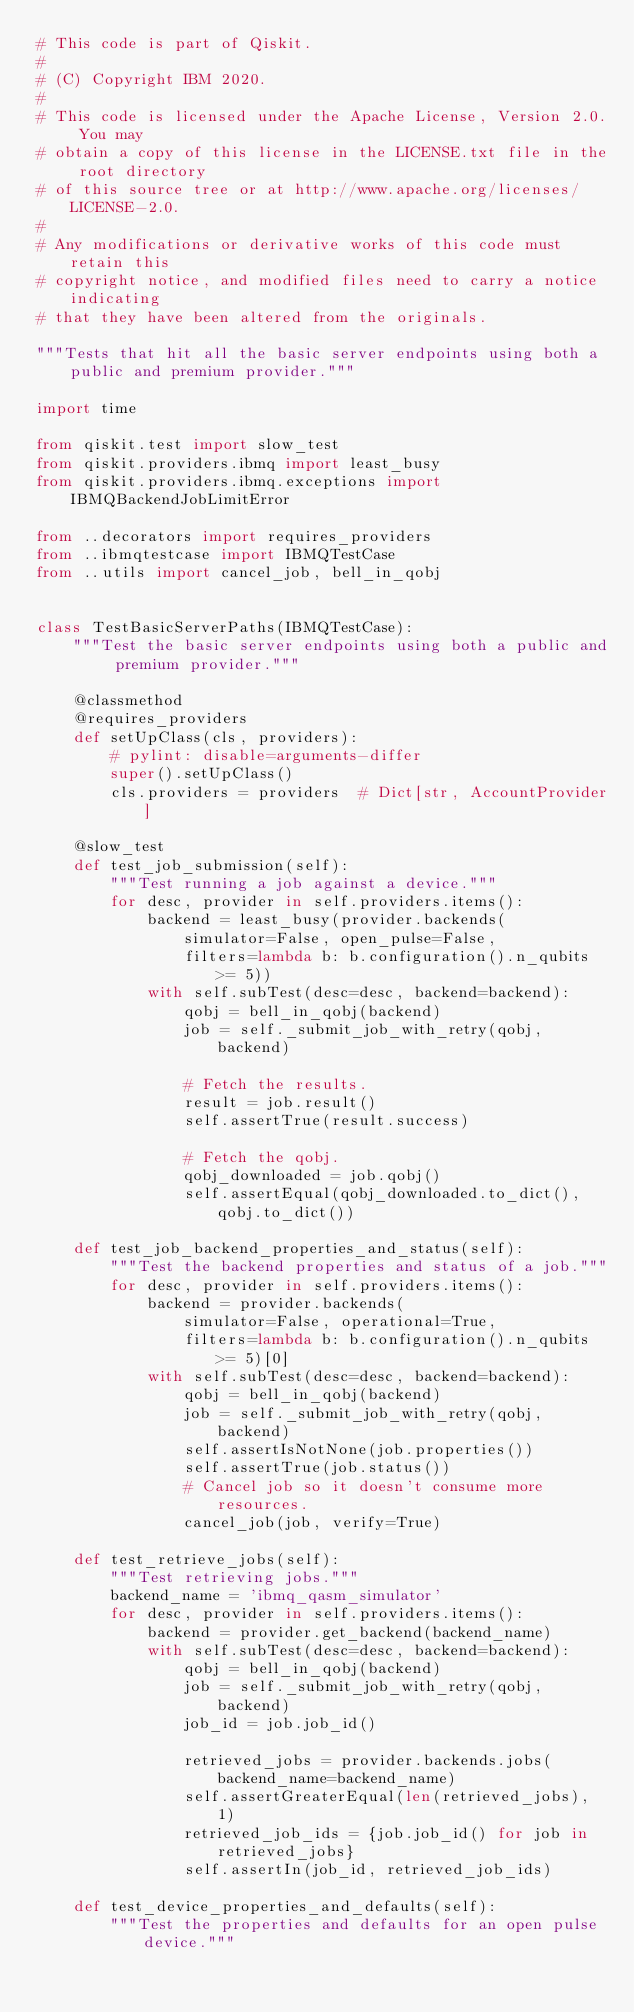Convert code to text. <code><loc_0><loc_0><loc_500><loc_500><_Python_># This code is part of Qiskit.
#
# (C) Copyright IBM 2020.
#
# This code is licensed under the Apache License, Version 2.0. You may
# obtain a copy of this license in the LICENSE.txt file in the root directory
# of this source tree or at http://www.apache.org/licenses/LICENSE-2.0.
#
# Any modifications or derivative works of this code must retain this
# copyright notice, and modified files need to carry a notice indicating
# that they have been altered from the originals.

"""Tests that hit all the basic server endpoints using both a public and premium provider."""

import time

from qiskit.test import slow_test
from qiskit.providers.ibmq import least_busy
from qiskit.providers.ibmq.exceptions import IBMQBackendJobLimitError

from ..decorators import requires_providers
from ..ibmqtestcase import IBMQTestCase
from ..utils import cancel_job, bell_in_qobj


class TestBasicServerPaths(IBMQTestCase):
    """Test the basic server endpoints using both a public and premium provider."""

    @classmethod
    @requires_providers
    def setUpClass(cls, providers):
        # pylint: disable=arguments-differ
        super().setUpClass()
        cls.providers = providers  # Dict[str, AccountProvider]

    @slow_test
    def test_job_submission(self):
        """Test running a job against a device."""
        for desc, provider in self.providers.items():
            backend = least_busy(provider.backends(
                simulator=False, open_pulse=False,
                filters=lambda b: b.configuration().n_qubits >= 5))
            with self.subTest(desc=desc, backend=backend):
                qobj = bell_in_qobj(backend)
                job = self._submit_job_with_retry(qobj, backend)

                # Fetch the results.
                result = job.result()
                self.assertTrue(result.success)

                # Fetch the qobj.
                qobj_downloaded = job.qobj()
                self.assertEqual(qobj_downloaded.to_dict(), qobj.to_dict())

    def test_job_backend_properties_and_status(self):
        """Test the backend properties and status of a job."""
        for desc, provider in self.providers.items():
            backend = provider.backends(
                simulator=False, operational=True,
                filters=lambda b: b.configuration().n_qubits >= 5)[0]
            with self.subTest(desc=desc, backend=backend):
                qobj = bell_in_qobj(backend)
                job = self._submit_job_with_retry(qobj, backend)
                self.assertIsNotNone(job.properties())
                self.assertTrue(job.status())
                # Cancel job so it doesn't consume more resources.
                cancel_job(job, verify=True)

    def test_retrieve_jobs(self):
        """Test retrieving jobs."""
        backend_name = 'ibmq_qasm_simulator'
        for desc, provider in self.providers.items():
            backend = provider.get_backend(backend_name)
            with self.subTest(desc=desc, backend=backend):
                qobj = bell_in_qobj(backend)
                job = self._submit_job_with_retry(qobj, backend)
                job_id = job.job_id()

                retrieved_jobs = provider.backends.jobs(backend_name=backend_name)
                self.assertGreaterEqual(len(retrieved_jobs), 1)
                retrieved_job_ids = {job.job_id() for job in retrieved_jobs}
                self.assertIn(job_id, retrieved_job_ids)

    def test_device_properties_and_defaults(self):
        """Test the properties and defaults for an open pulse device."""</code> 